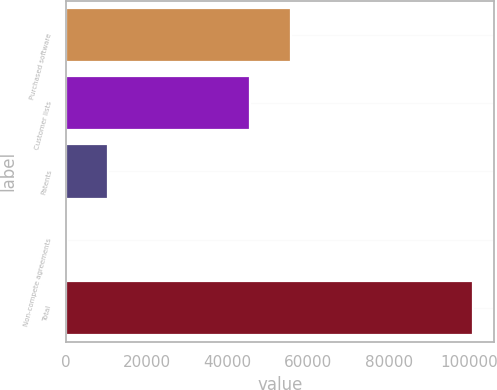Convert chart to OTSL. <chart><loc_0><loc_0><loc_500><loc_500><bar_chart><fcel>Purchased software<fcel>Customer lists<fcel>Patents<fcel>Non-compete agreements<fcel>Total<nl><fcel>55692.5<fcel>45642<fcel>10432.5<fcel>382<fcel>100887<nl></chart> 